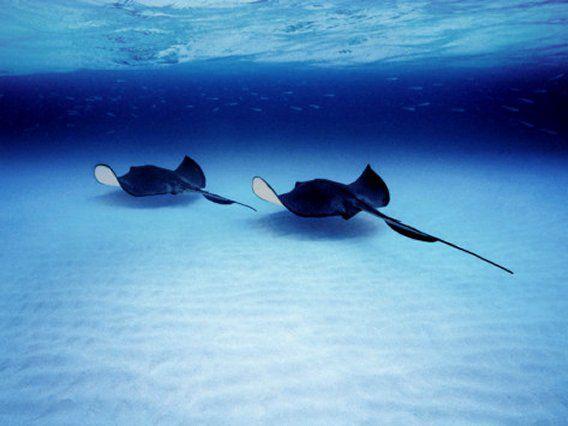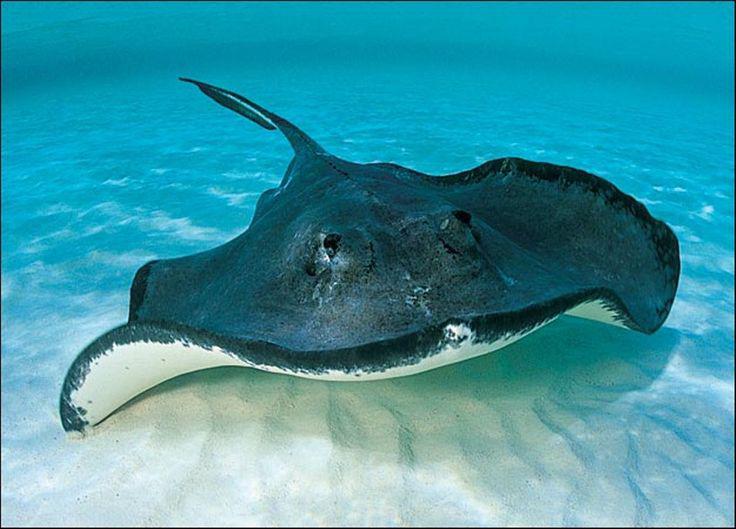The first image is the image on the left, the second image is the image on the right. For the images displayed, is the sentence "There are no more than two stingrays." factually correct? Answer yes or no. No. The first image is the image on the left, the second image is the image on the right. Evaluate the accuracy of this statement regarding the images: "There are exactly two animals in the image on the left.". Is it true? Answer yes or no. Yes. 